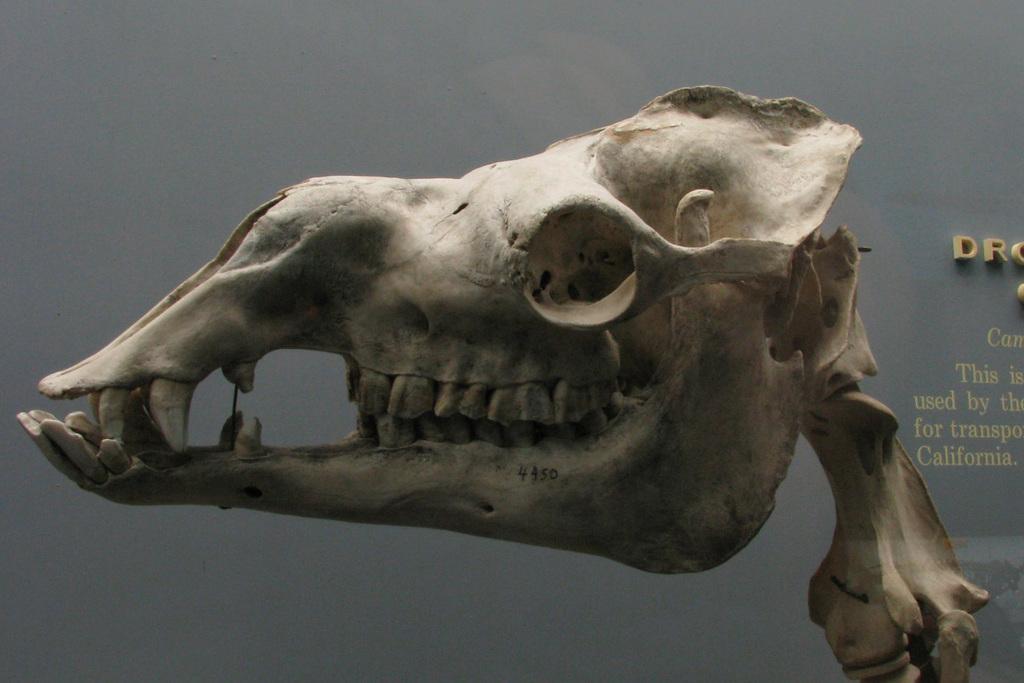What is the main subject of the image? The main subject of the image is a skull of an animal. Can you describe anything else in the image besides the skull? Yes, there is something written on the wall in the image. What type of friction can be seen between the skull and the wall in the image? There is no friction visible between the skull and the wall in the image, as they are not interacting with each other. 